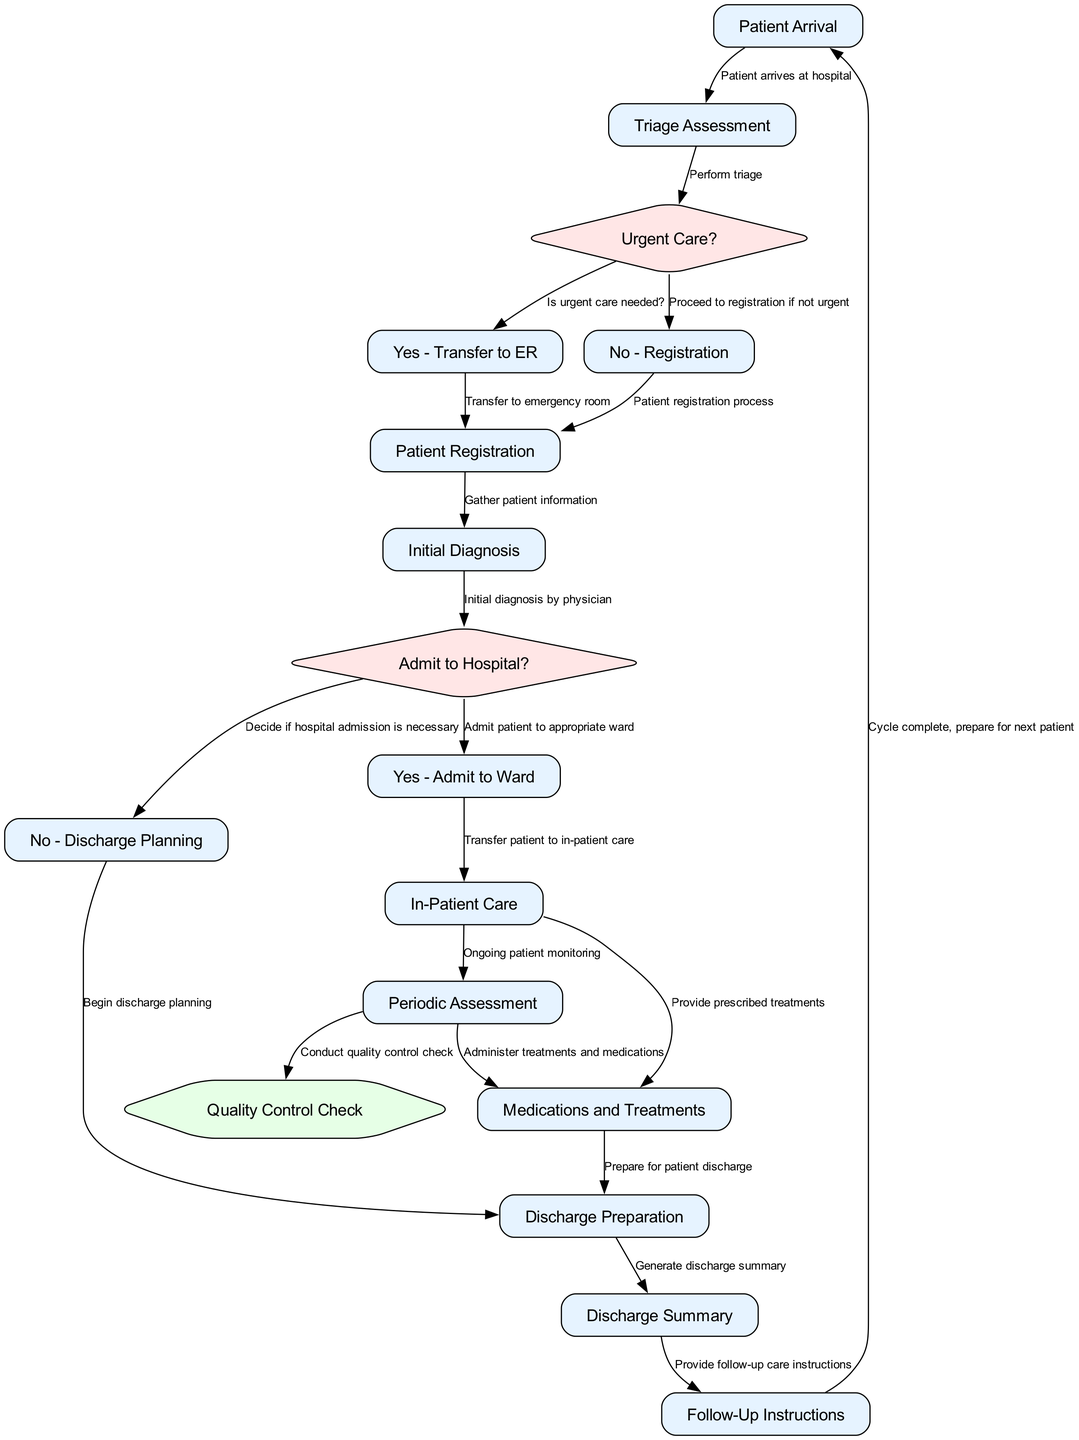What is the first step in the patient admission process? The first step in the patient admission process is defined as "Patient Arrival." This is the initial node depicted at the top of the diagram.
Answer: Patient Arrival How many decision points are present in the diagram? The decision points are represented by nodes that end with a question mark. In this diagram, there are three such question nodes: "Urgent Care?", "Admit to Hospital?", and "Discharge Planning." Counting these gives a total of three decision points.
Answer: 3 What happens if urgent care is not needed? If urgent care is not needed, the process flows from "Urgent Care?" to "No - Registration," leading to the next phase of "Patient Registration." Thus, the patient is directed to register instead of going to the emergency room.
Answer: Proceed to registration What is the relationship between "Periodic Assessment" and "Quality Control Check"? "Periodic Assessment" leads to "Quality Control Check." This means that the quality control check follows the periodic assessment step, which is part of the ongoing patient monitoring process.
Answer: Conduct quality control check How do patients receive follow-up care instructions? After generating the "Discharge Summary," the process flows to the "Follow-Up Instructions." This means that the instructions are provided directly after the summary has been created, ensuring patients know the next steps before leaving.
Answer: Provide follow-up care instructions What is the last step in the patient flow process? The last step is represented by the node labeled "Cycle complete, prepare for next patient." This indicates that the process is cyclical and can begin again with a new patient following discharge.
Answer: Cycle complete, prepare for next patient What type of treatments are administered before discharge? The treatments administered before discharge are labeled as "Medications and Treatments." This includes any medical care the patient requires before they leave the hospital.
Answer: Medications and Treatments What is the purpose of the "Quality Control Check"? The "Quality Control Check" is performed to ensure standards and quality measures are met during the "Ongoing patient monitoring." This step is crucial for assessing the quality of care provided to the patient.
Answer: Ensure quality measures are met 